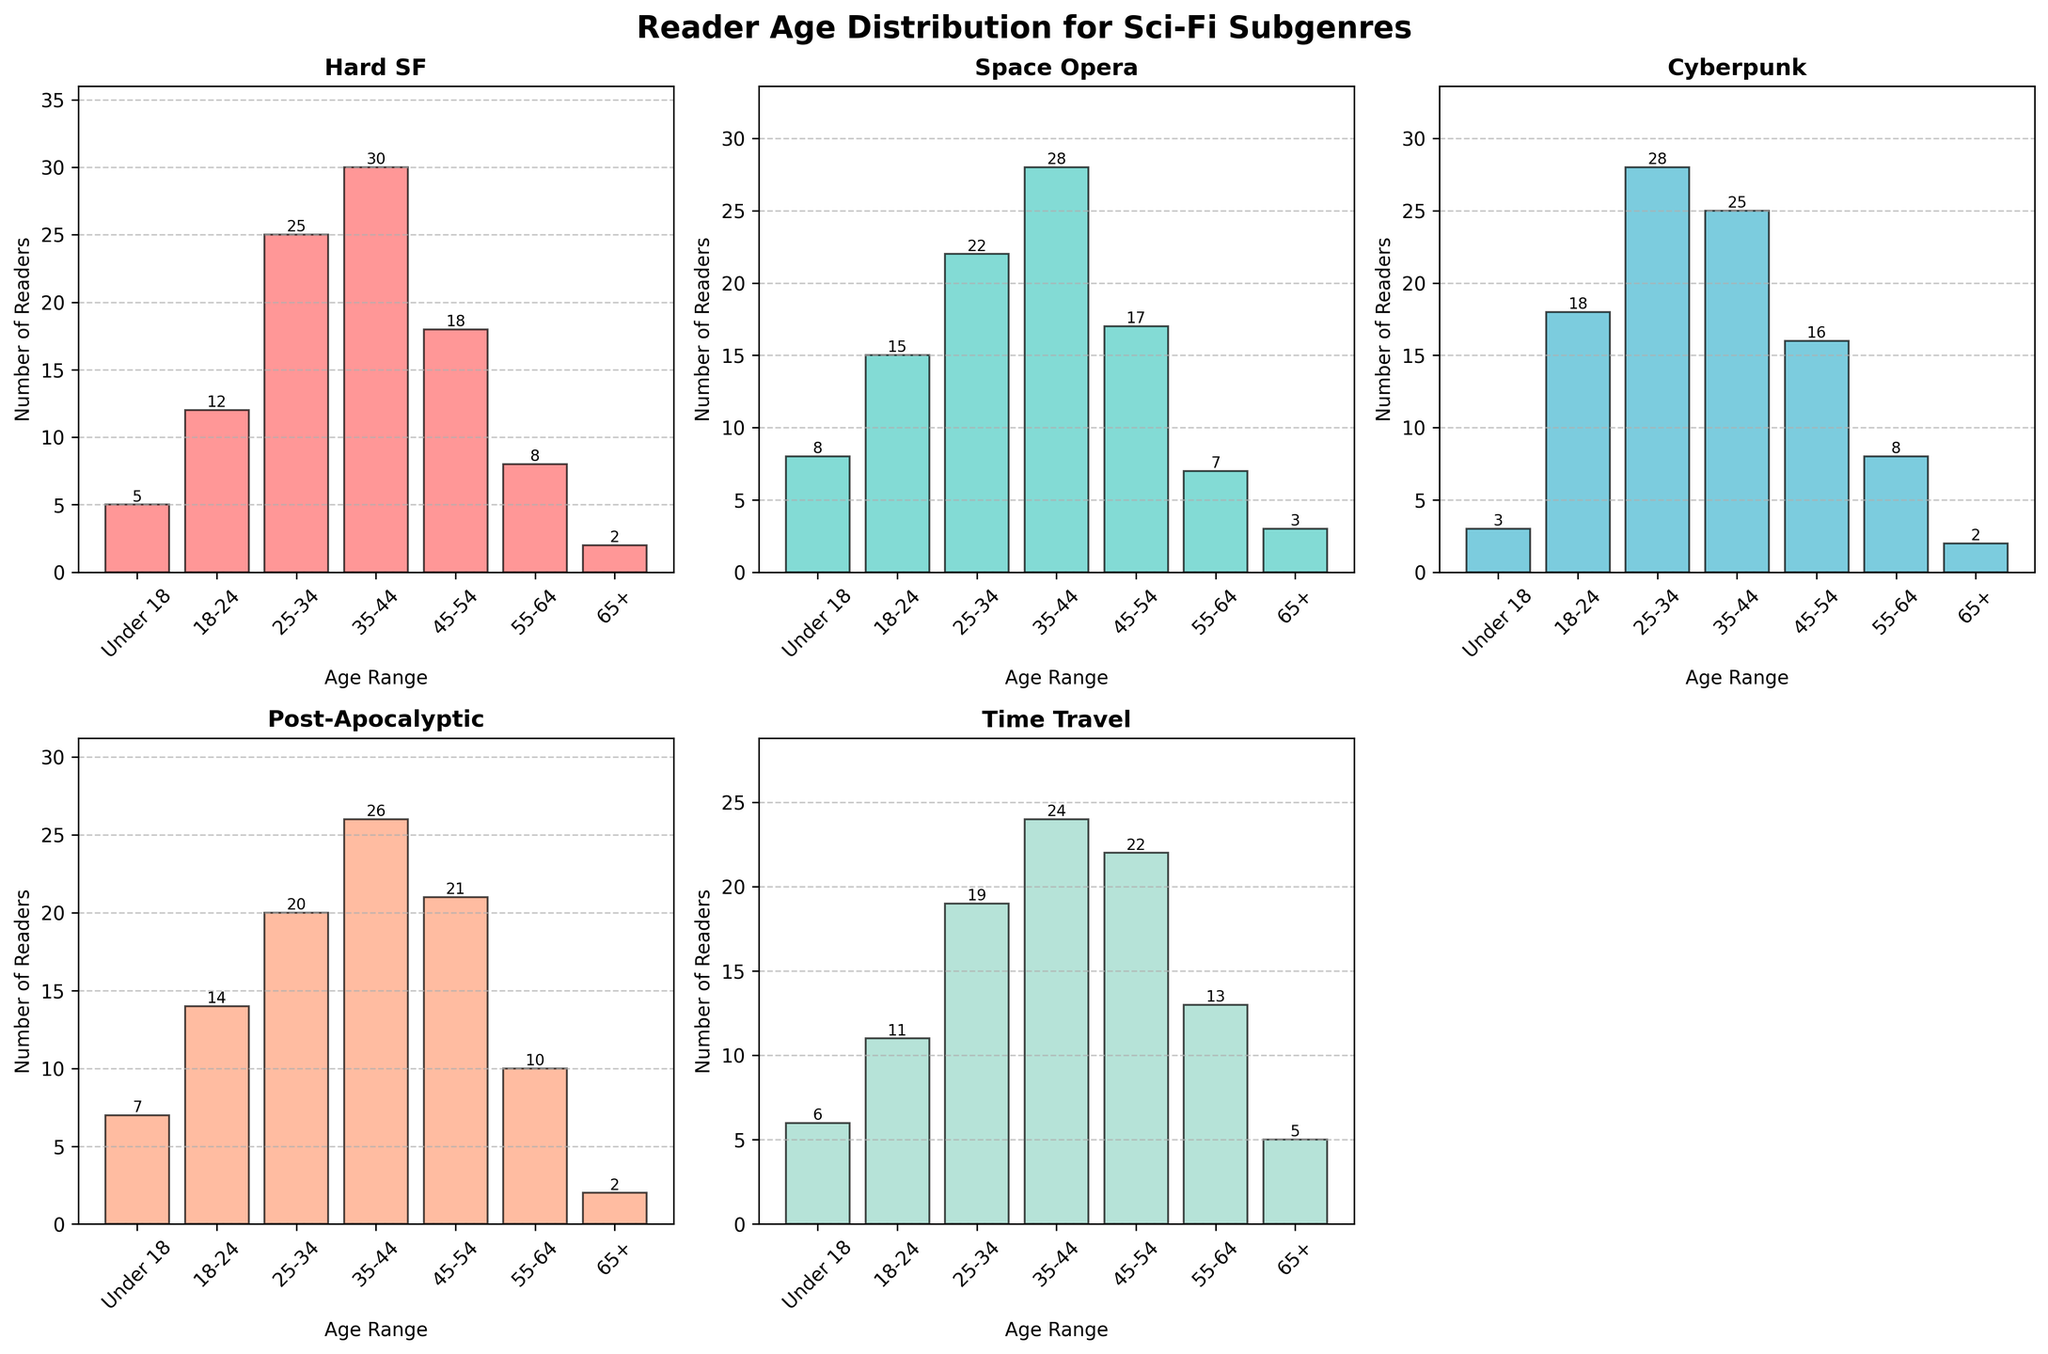What is the title of the figure? The title of the figure is written at the top and it clearly states what the figure represents. It reads "Reader Age Distribution for Sci-Fi Subgenres".
Answer: Reader Age Distribution for Sci-Fi Subgenres Which subgenre has the highest number of readers in the 35-44 age range? By observing the bar heights in the 35-44 age range for each subgenre subplot, the tallest bar represents the Hard SF subgenre with 30 readers.
Answer: Hard SF How many total readers are there in the 25-34 age range across all subgenres? Sum the values for the 25-34 age range from all subgenres: 25 (Hard SF) + 22 (Space Opera) + 28 (Cyberpunk) + 20 (Post-Apocalyptic) + 19 (Time Travel) = 114.
Answer: 114 Which subgenre shows the smallest increase in readership from the 18-24 to the 25-34 age ranges? Calculate the difference between the 25-34 and 18-24 age ranges for each subgenre. The smallest difference is for Hard SF: 25-12=13.
Answer: Hard SF What age range has the lowest number of readers for any subgenre, and which subgenre does it correspond to? The lowest bar at any subplot shows 2 readers in the "Under 18" and "65+" age ranges for Hard SF, Cyberpunk, and Post-Apocalyptic subgenres.
Answer: [Under 18 for Hard SF], [65+ for Hard SF], [65+ for Cyberpunk], [65+ for Post-Apocalyptic] How does the reader distribution for the "Post-Apocalyptic" subgenre compare to the "Time Travel" subgenre for readers aged 45-54? By comparing the bar heights for the 45-54 age range in both subgenres, Post-Apocalyptic has a slightly higher bar at 21, while Time Travel has a bar at 22.
Answer: Post-Apocalyptic: 21, Time Travel: 22 Does the "Space Opera" subgenre have more readers aged under 18 or over 65? By comparing the heights of the bars for under 18 (8 readers) and over 65 (3 readers) in the Space Opera subplot, the bar for under 18 is taller.
Answer: Under 18 Which subgenre appears to have the most balanced age distribution? By visually comparing the heights of the bars across all age ranges in each subplot, Cyberpunk has bars of varying heights but none dominate significantly over others, indicating a more balanced age distribution.
Answer: Cyberpunk What are the exact reader numbers for the "Cyberpunk" subgenre in the age ranges "Under 18" and "65+"? Refer to the Cyberpunk subplot and read the values from these age ranges: 3 readers for "Under 18" and 2 readers for "65+".
Answer: [Under 18: 3], [65+: 2] How many readers are there in the "18-24" age range for the "Space Opera" subgenre? Look at the bar height in the "18-24" age range for the Space Opera subplot, which shows 15 readers.
Answer: 15 